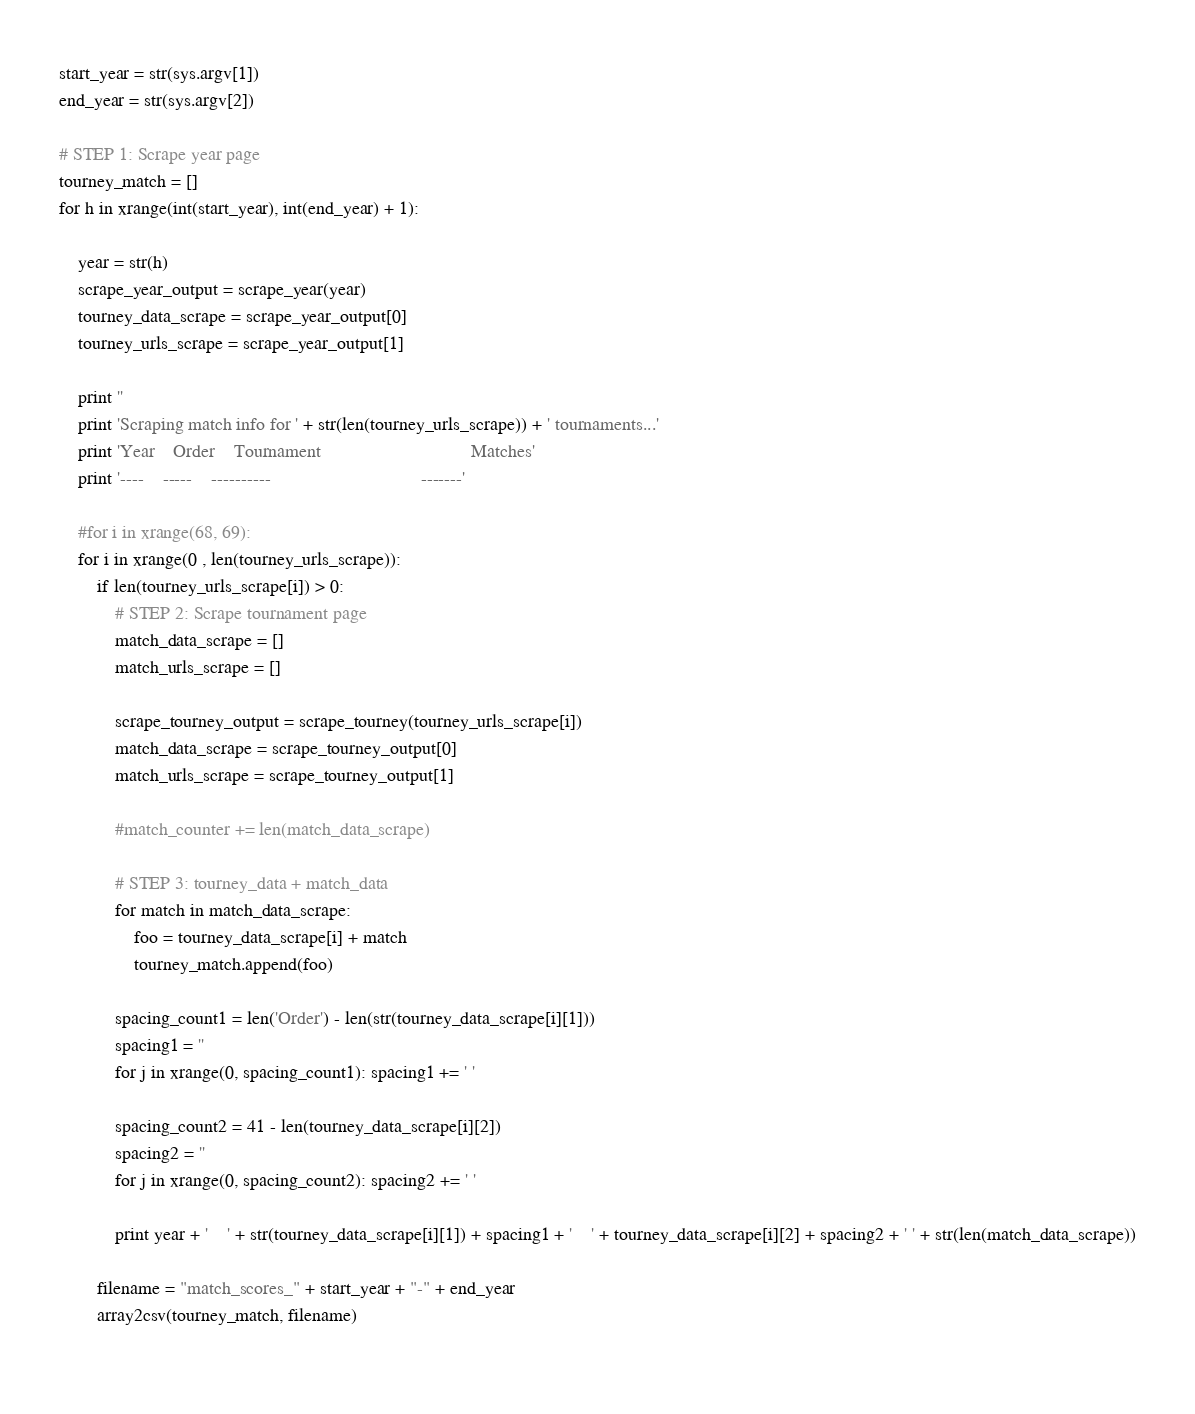<code> <loc_0><loc_0><loc_500><loc_500><_Python_>start_year = str(sys.argv[1])
end_year = str(sys.argv[2])

# STEP 1: Scrape year page
tourney_match = []
for h in xrange(int(start_year), int(end_year) + 1):

    year = str(h)
    scrape_year_output = scrape_year(year)
    tourney_data_scrape = scrape_year_output[0]
    tourney_urls_scrape = scrape_year_output[1]

    print ''
    print 'Scraping match info for ' + str(len(tourney_urls_scrape)) + ' tournaments...'
    print 'Year    Order    Tournament                                Matches'
    print '----    -----    ----------                                -------'
    
    #for i in xrange(68, 69):
    for i in xrange(0 , len(tourney_urls_scrape)):
        if len(tourney_urls_scrape[i]) > 0:
            # STEP 2: Scrape tournament page    
            match_data_scrape = []
            match_urls_scrape = []

            scrape_tourney_output = scrape_tourney(tourney_urls_scrape[i])
            match_data_scrape = scrape_tourney_output[0]
            match_urls_scrape = scrape_tourney_output[1]
     
            #match_counter += len(match_data_scrape)

            # STEP 3: tourney_data + match_data
            for match in match_data_scrape:
                foo = tourney_data_scrape[i] + match
                tourney_match.append(foo)

            spacing_count1 = len('Order') - len(str(tourney_data_scrape[i][1]))
            spacing1 = ''
            for j in xrange(0, spacing_count1): spacing1 += ' '

            spacing_count2 = 41 - len(tourney_data_scrape[i][2])
            spacing2 = ''
            for j in xrange(0, spacing_count2): spacing2 += ' '            

            print year + '    ' + str(tourney_data_scrape[i][1]) + spacing1 + '    ' + tourney_data_scrape[i][2] + spacing2 + ' ' + str(len(match_data_scrape))

        filename = "match_scores_" + start_year + "-" + end_year
        array2csv(tourney_match, filename)
        
</code> 